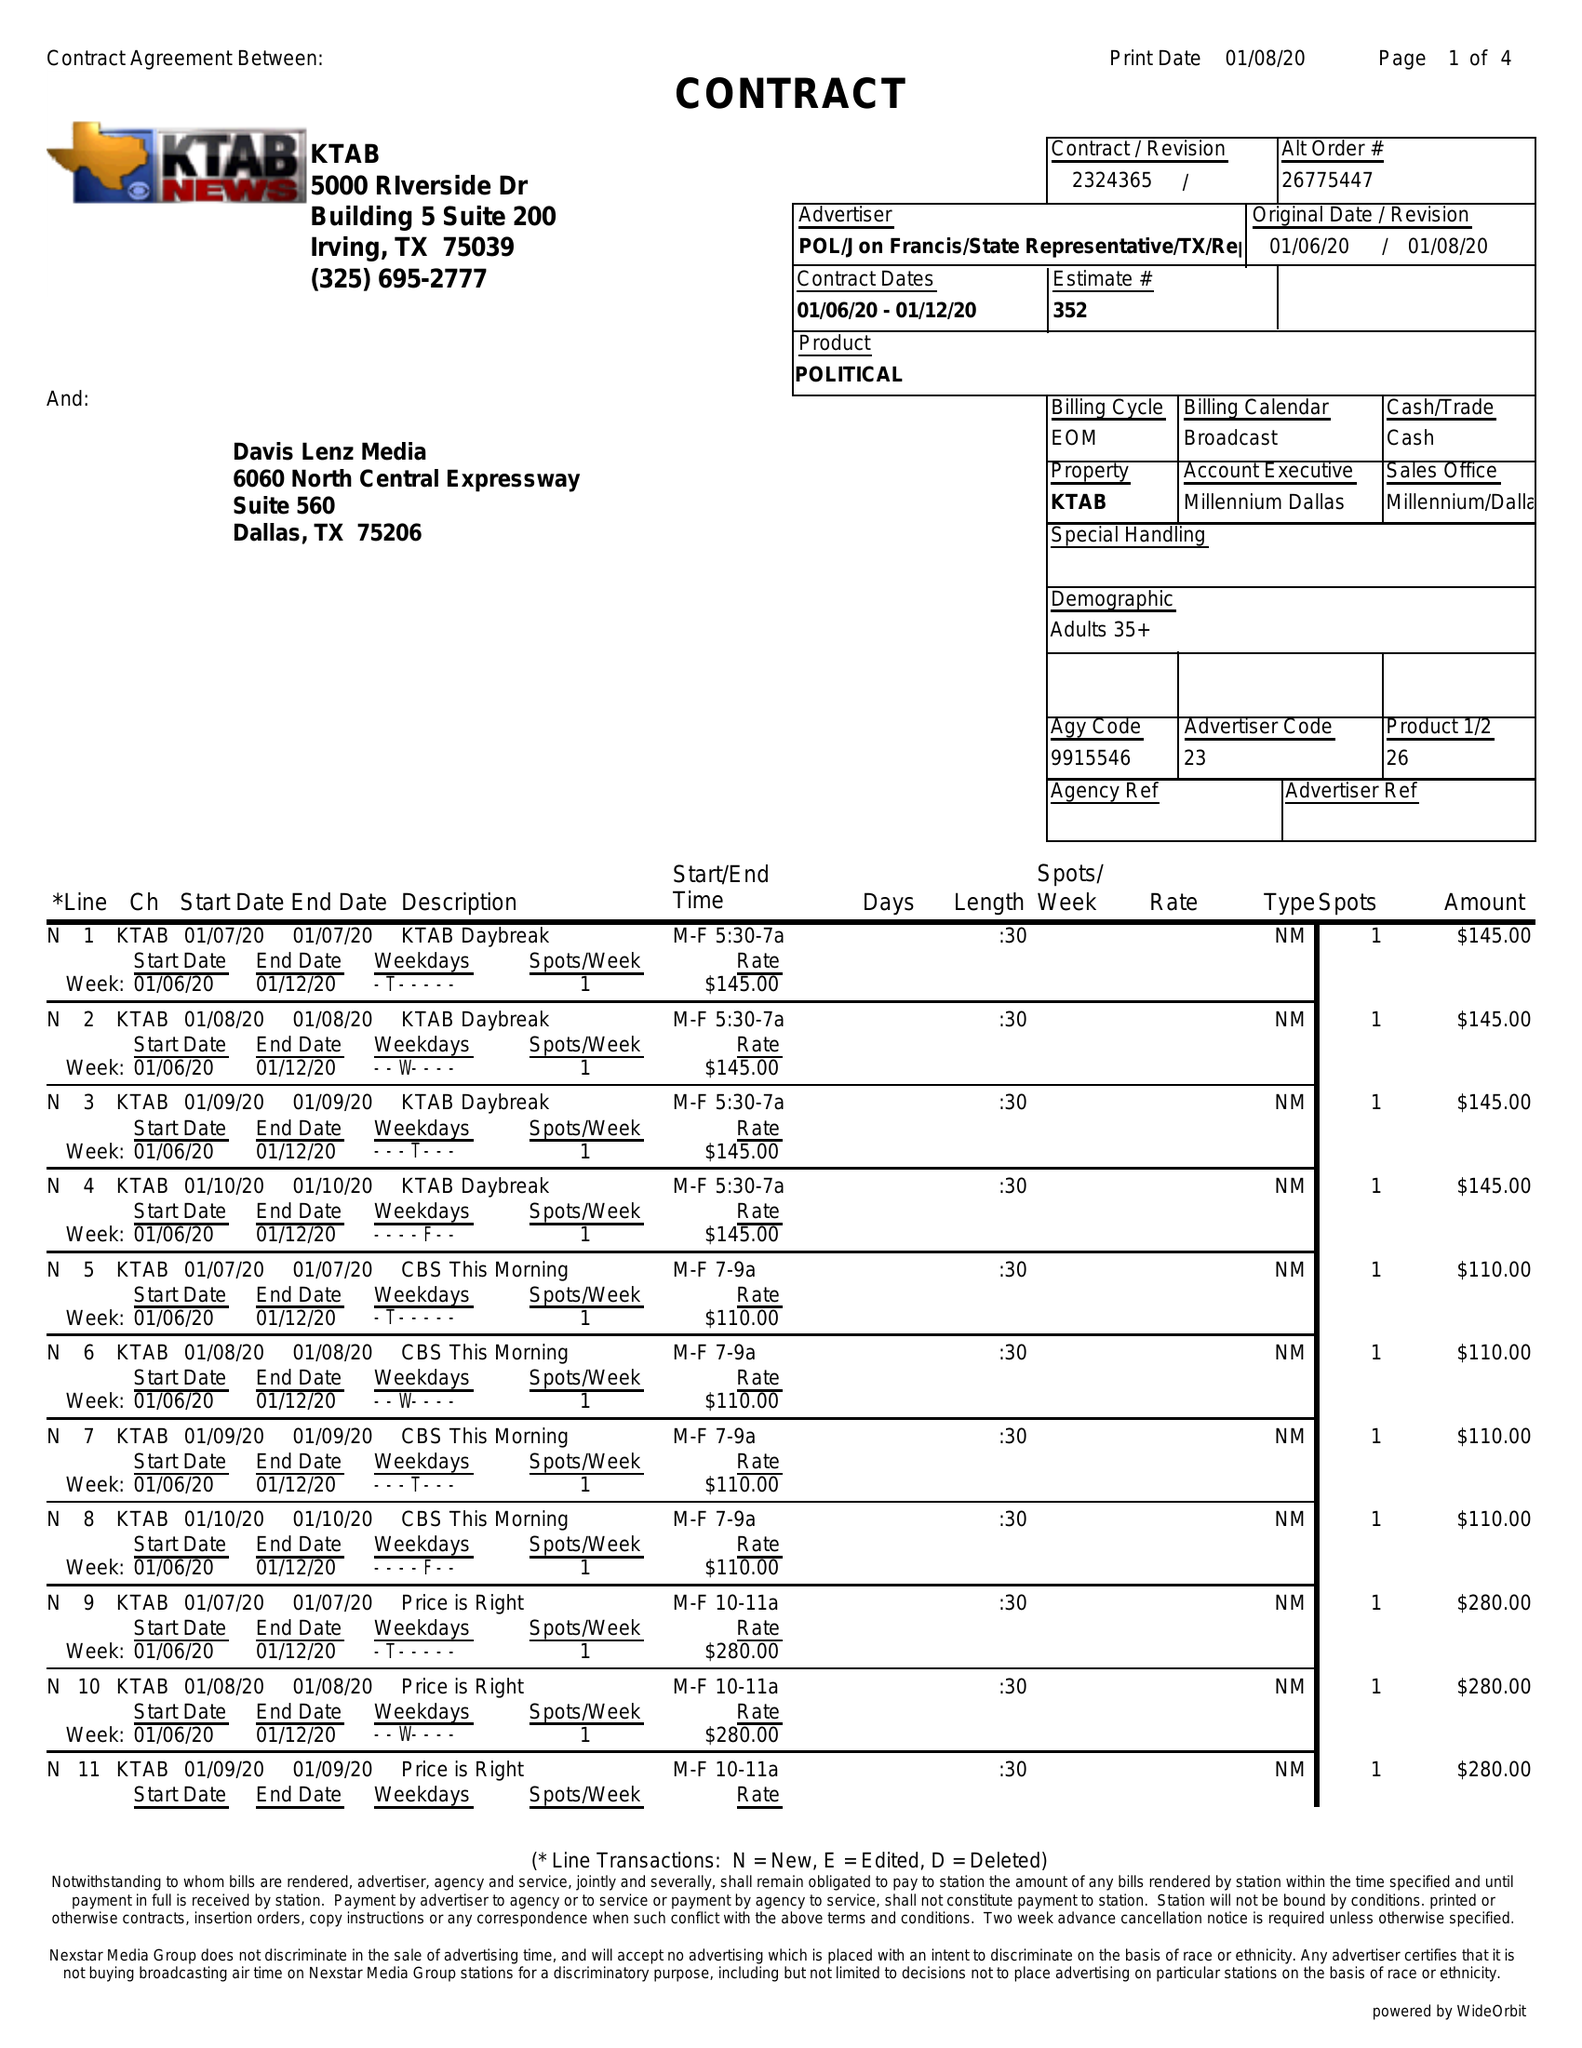What is the value for the gross_amount?
Answer the question using a single word or phrase. 10895.00 